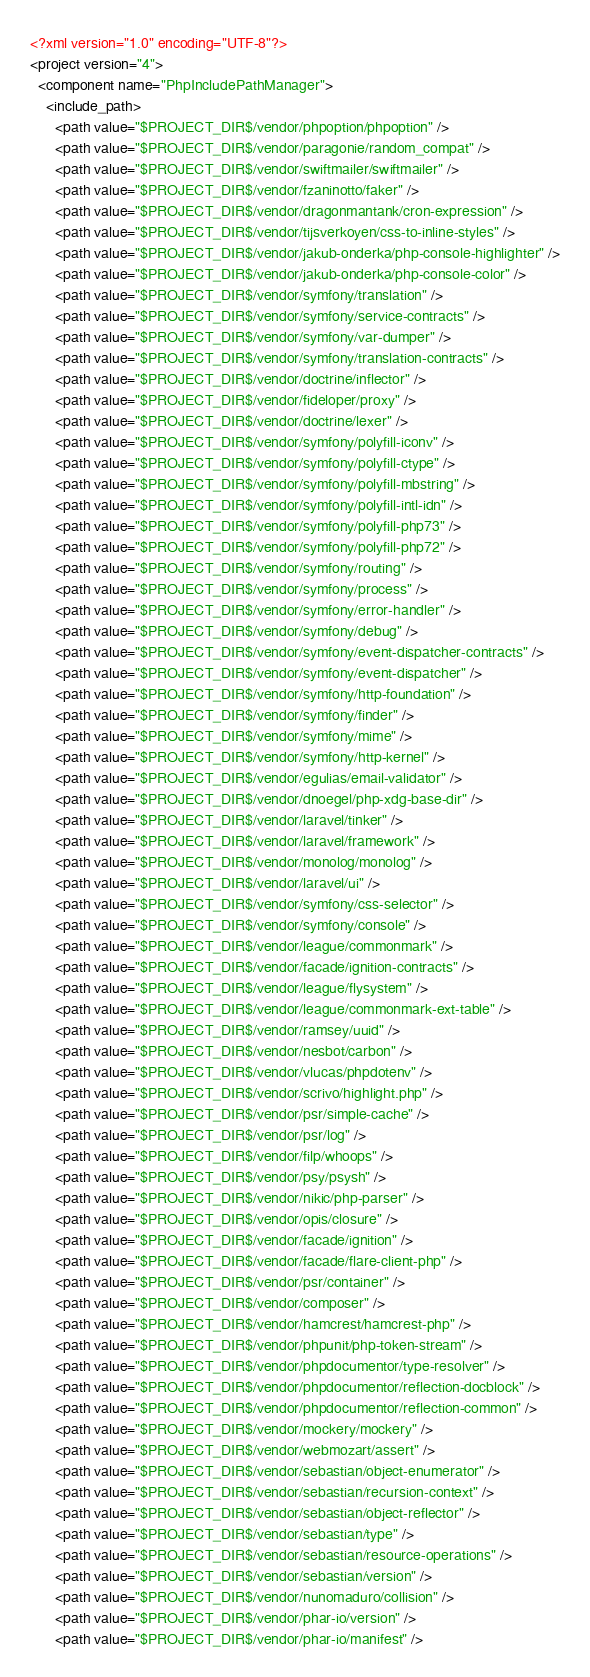Convert code to text. <code><loc_0><loc_0><loc_500><loc_500><_XML_><?xml version="1.0" encoding="UTF-8"?>
<project version="4">
  <component name="PhpIncludePathManager">
    <include_path>
      <path value="$PROJECT_DIR$/vendor/phpoption/phpoption" />
      <path value="$PROJECT_DIR$/vendor/paragonie/random_compat" />
      <path value="$PROJECT_DIR$/vendor/swiftmailer/swiftmailer" />
      <path value="$PROJECT_DIR$/vendor/fzaninotto/faker" />
      <path value="$PROJECT_DIR$/vendor/dragonmantank/cron-expression" />
      <path value="$PROJECT_DIR$/vendor/tijsverkoyen/css-to-inline-styles" />
      <path value="$PROJECT_DIR$/vendor/jakub-onderka/php-console-highlighter" />
      <path value="$PROJECT_DIR$/vendor/jakub-onderka/php-console-color" />
      <path value="$PROJECT_DIR$/vendor/symfony/translation" />
      <path value="$PROJECT_DIR$/vendor/symfony/service-contracts" />
      <path value="$PROJECT_DIR$/vendor/symfony/var-dumper" />
      <path value="$PROJECT_DIR$/vendor/symfony/translation-contracts" />
      <path value="$PROJECT_DIR$/vendor/doctrine/inflector" />
      <path value="$PROJECT_DIR$/vendor/fideloper/proxy" />
      <path value="$PROJECT_DIR$/vendor/doctrine/lexer" />
      <path value="$PROJECT_DIR$/vendor/symfony/polyfill-iconv" />
      <path value="$PROJECT_DIR$/vendor/symfony/polyfill-ctype" />
      <path value="$PROJECT_DIR$/vendor/symfony/polyfill-mbstring" />
      <path value="$PROJECT_DIR$/vendor/symfony/polyfill-intl-idn" />
      <path value="$PROJECT_DIR$/vendor/symfony/polyfill-php73" />
      <path value="$PROJECT_DIR$/vendor/symfony/polyfill-php72" />
      <path value="$PROJECT_DIR$/vendor/symfony/routing" />
      <path value="$PROJECT_DIR$/vendor/symfony/process" />
      <path value="$PROJECT_DIR$/vendor/symfony/error-handler" />
      <path value="$PROJECT_DIR$/vendor/symfony/debug" />
      <path value="$PROJECT_DIR$/vendor/symfony/event-dispatcher-contracts" />
      <path value="$PROJECT_DIR$/vendor/symfony/event-dispatcher" />
      <path value="$PROJECT_DIR$/vendor/symfony/http-foundation" />
      <path value="$PROJECT_DIR$/vendor/symfony/finder" />
      <path value="$PROJECT_DIR$/vendor/symfony/mime" />
      <path value="$PROJECT_DIR$/vendor/symfony/http-kernel" />
      <path value="$PROJECT_DIR$/vendor/egulias/email-validator" />
      <path value="$PROJECT_DIR$/vendor/dnoegel/php-xdg-base-dir" />
      <path value="$PROJECT_DIR$/vendor/laravel/tinker" />
      <path value="$PROJECT_DIR$/vendor/laravel/framework" />
      <path value="$PROJECT_DIR$/vendor/monolog/monolog" />
      <path value="$PROJECT_DIR$/vendor/laravel/ui" />
      <path value="$PROJECT_DIR$/vendor/symfony/css-selector" />
      <path value="$PROJECT_DIR$/vendor/symfony/console" />
      <path value="$PROJECT_DIR$/vendor/league/commonmark" />
      <path value="$PROJECT_DIR$/vendor/facade/ignition-contracts" />
      <path value="$PROJECT_DIR$/vendor/league/flysystem" />
      <path value="$PROJECT_DIR$/vendor/league/commonmark-ext-table" />
      <path value="$PROJECT_DIR$/vendor/ramsey/uuid" />
      <path value="$PROJECT_DIR$/vendor/nesbot/carbon" />
      <path value="$PROJECT_DIR$/vendor/vlucas/phpdotenv" />
      <path value="$PROJECT_DIR$/vendor/scrivo/highlight.php" />
      <path value="$PROJECT_DIR$/vendor/psr/simple-cache" />
      <path value="$PROJECT_DIR$/vendor/psr/log" />
      <path value="$PROJECT_DIR$/vendor/filp/whoops" />
      <path value="$PROJECT_DIR$/vendor/psy/psysh" />
      <path value="$PROJECT_DIR$/vendor/nikic/php-parser" />
      <path value="$PROJECT_DIR$/vendor/opis/closure" />
      <path value="$PROJECT_DIR$/vendor/facade/ignition" />
      <path value="$PROJECT_DIR$/vendor/facade/flare-client-php" />
      <path value="$PROJECT_DIR$/vendor/psr/container" />
      <path value="$PROJECT_DIR$/vendor/composer" />
      <path value="$PROJECT_DIR$/vendor/hamcrest/hamcrest-php" />
      <path value="$PROJECT_DIR$/vendor/phpunit/php-token-stream" />
      <path value="$PROJECT_DIR$/vendor/phpdocumentor/type-resolver" />
      <path value="$PROJECT_DIR$/vendor/phpdocumentor/reflection-docblock" />
      <path value="$PROJECT_DIR$/vendor/phpdocumentor/reflection-common" />
      <path value="$PROJECT_DIR$/vendor/mockery/mockery" />
      <path value="$PROJECT_DIR$/vendor/webmozart/assert" />
      <path value="$PROJECT_DIR$/vendor/sebastian/object-enumerator" />
      <path value="$PROJECT_DIR$/vendor/sebastian/recursion-context" />
      <path value="$PROJECT_DIR$/vendor/sebastian/object-reflector" />
      <path value="$PROJECT_DIR$/vendor/sebastian/type" />
      <path value="$PROJECT_DIR$/vendor/sebastian/resource-operations" />
      <path value="$PROJECT_DIR$/vendor/sebastian/version" />
      <path value="$PROJECT_DIR$/vendor/nunomaduro/collision" />
      <path value="$PROJECT_DIR$/vendor/phar-io/version" />
      <path value="$PROJECT_DIR$/vendor/phar-io/manifest" /></code> 